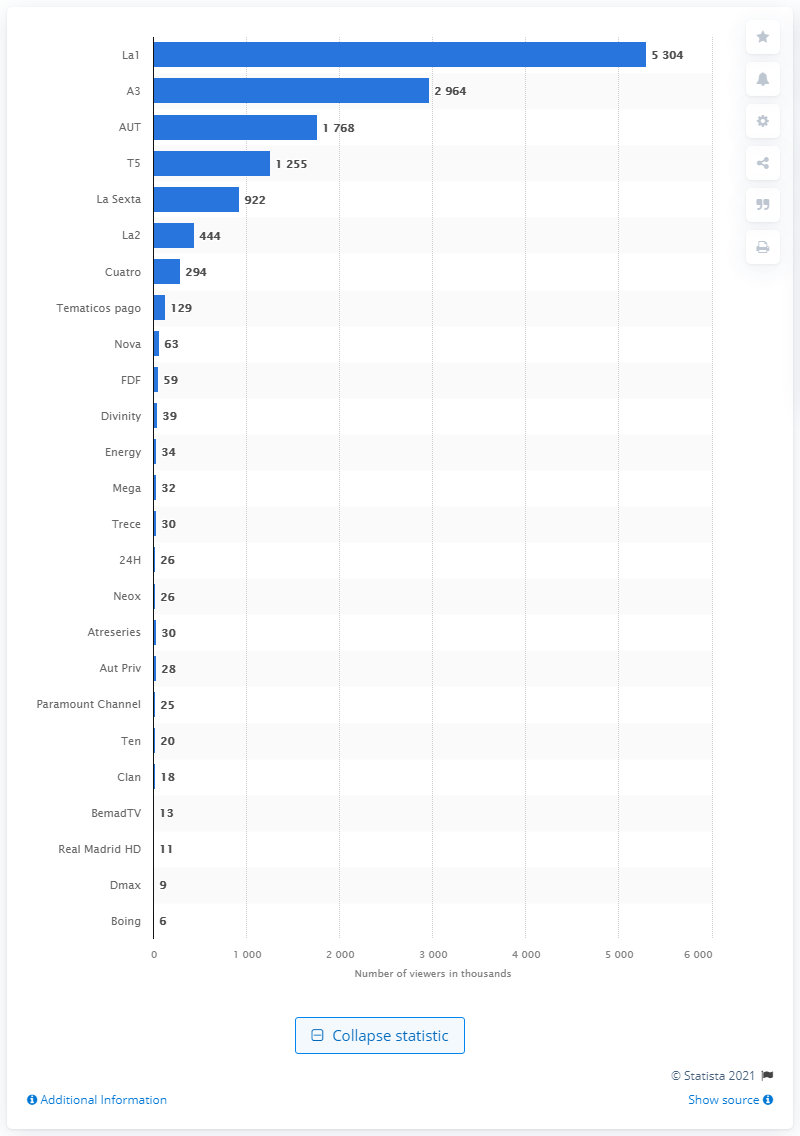Outline some significant characteristics in this image. The most popular channel for watching the traditional campanada program was La1. 